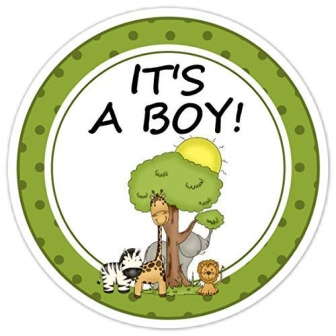Create a short story inspired by this sticker. In a sunlit savanna, Giraffe, Lion, Zebra, and their little bird friend gathered to celebrate the birth of a newborn prince. They decorated the base of a grand, shading tree with vibrant flowers and leaves. Laughter and joy filled the air as they played games, sang songs, and welcomed the newest member of their wild family. Above them, the sky bore the announcement, 'IT'S A BOY!' marking a new beginning in the heart of the wilderness. 